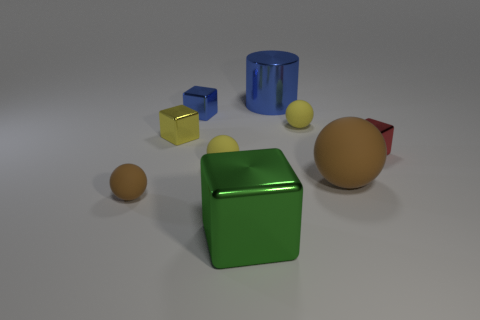Subtract all green blocks. How many blocks are left? 3 Subtract all tiny brown balls. How many balls are left? 3 Subtract all cylinders. How many objects are left? 8 Subtract 2 spheres. How many spheres are left? 2 Subtract all green cylinders. How many red blocks are left? 1 Subtract all small yellow spheres. Subtract all small brown rubber spheres. How many objects are left? 6 Add 2 big rubber spheres. How many big rubber spheres are left? 3 Add 8 small cyan shiny cubes. How many small cyan shiny cubes exist? 8 Subtract 1 red cubes. How many objects are left? 8 Subtract all green spheres. Subtract all cyan cylinders. How many spheres are left? 4 